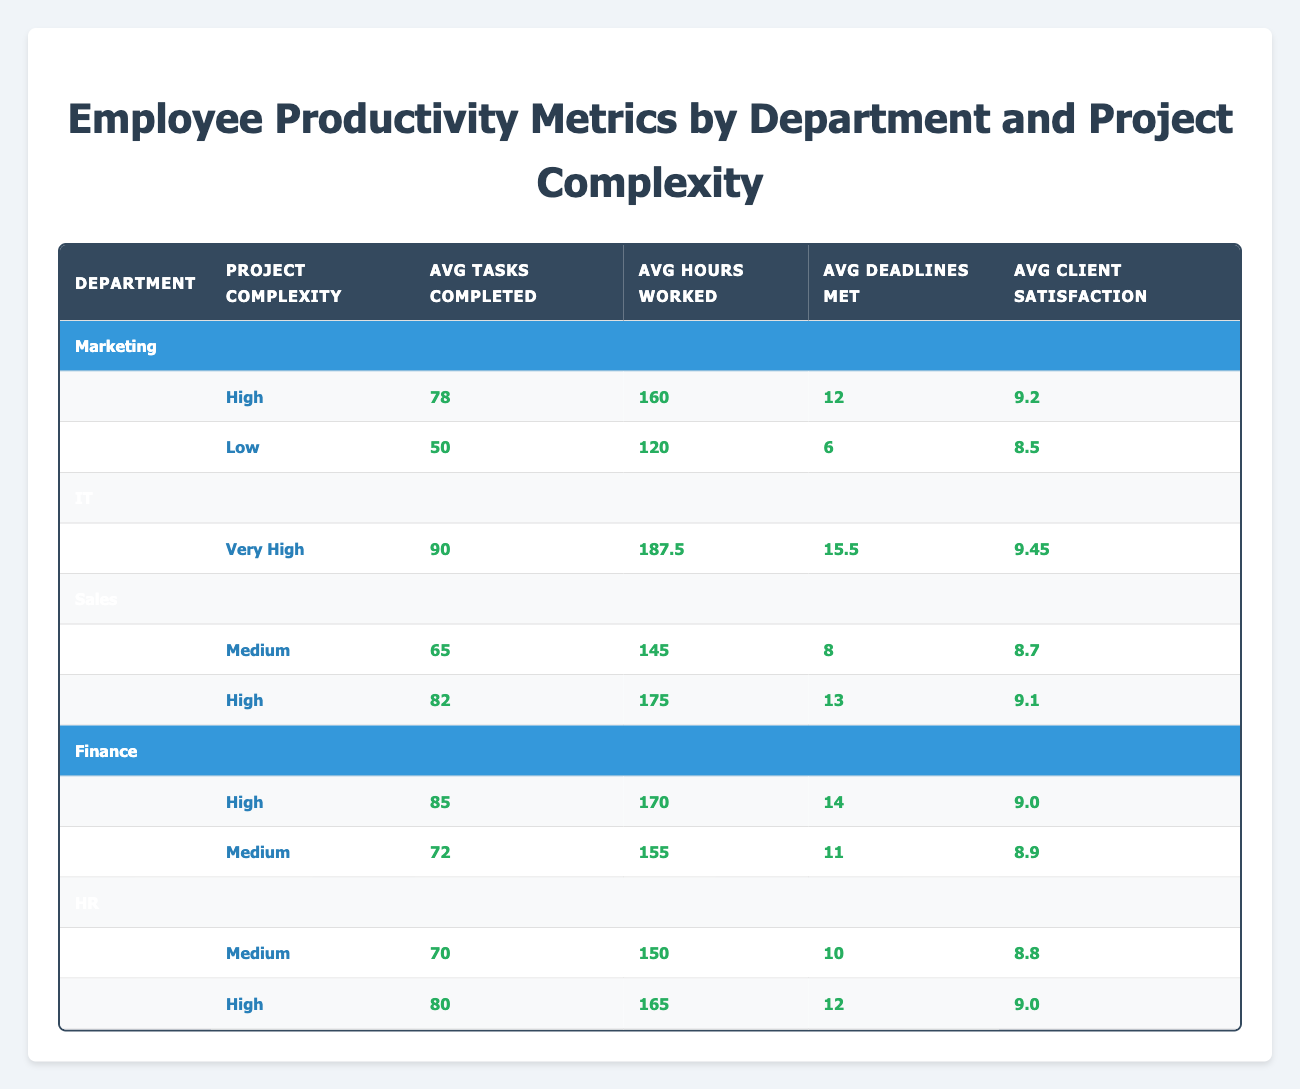What is the average number of tasks completed in the IT department? In the IT department, there are two records: Michael Chen completed 92 tasks, and Alex Patel completed 88 tasks. To find the average, sum these values (92 + 88 = 180) and divide by the number of records (2), which results in 180 / 2 = 90.
Answer: 90 What is the highest client satisfaction score among all employees? Reviewing the client satisfaction scores, Sarah Johnson has 9.2, Michael Chen has 9.5, Emma Rodriguez has 8.7, David Kim has 9.0, Laura Thompson has 8.8, Alex Patel has 9.4, Sophia Lee has 8.5, James Wilson has 9.1, Olivia Brown has 8.9, and Daniel Garcia has 9.0. The highest score is 9.5 from Michael Chen.
Answer: 9.5 How many deadlines did the employees in the Sales department meet in total? In the Sales department, Emma Rodriguez met 8 deadlines, and James Wilson met 13 deadlines. Summing these gives 8 + 13 = 21 deadlines met in total.
Answer: 21 Is the average hours worked for high complexity projects greater than 160? Analyzing the high complexity projects, we have Sarah Johnson (160 hours), David Kim (170 hours), and James Wilson (175 hours), resulting in an average of (160 + 170 + 175) / 3 = 168.33 hours, which is less than 160. Hence the statement is false.
Answer: No What is the difference between the average tasks completed for high and medium complexity projects in the HR department? For the HR department, Daniel Garcia completed 80 tasks for high complexity, while Laura Thompson completed 70 tasks for medium complexity. The average for high is 80, and for medium is 70. The difference is 80 - 70 = 10.
Answer: 10 What is the average client satisfaction for the Finance department? In the Finance department, David Kim has 9.0 client satisfaction, and Olivia Brown has 8.9. The average is (9.0 + 8.9) / 2 = 8.95.
Answer: 8.95 Are there more tasks completed on average in high complexity projects compared to low complexity projects in the Marketing department? In Marketing, Sarah Johnson completed 78 tasks for high complexity, while Sophia Lee completed 50 tasks for low complexity. The average for high complexity is 78, and for low complexity is 50. Since 78 is greater than 50, the statement is true.
Answer: Yes What is the total hours worked by employees in the IT department? For the IT department, Michael Chen worked 185 hours, and Alex Patel worked 190 hours. Adding these gives a total of 185 + 190 = 375 hours worked.
Answer: 375 